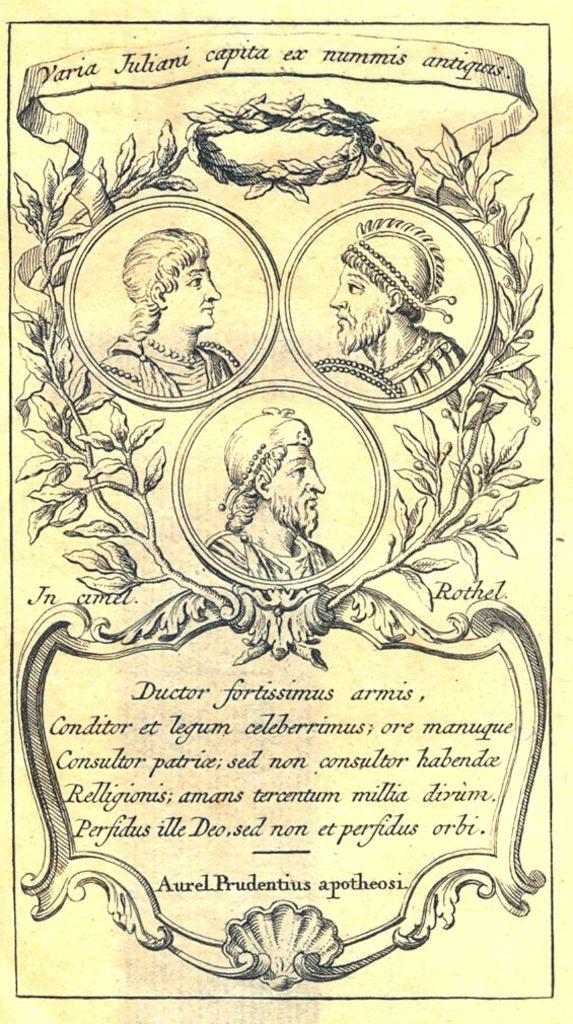How many people are in the image? There are three persons in the image. What can be seen above the persons in the image? There is text written above the persons. What can be seen below the persons in the image? There is text written below the persons. What type of fish can be seen swimming in the text below the persons? There are no fish present in the image; the text is not a body of water. 